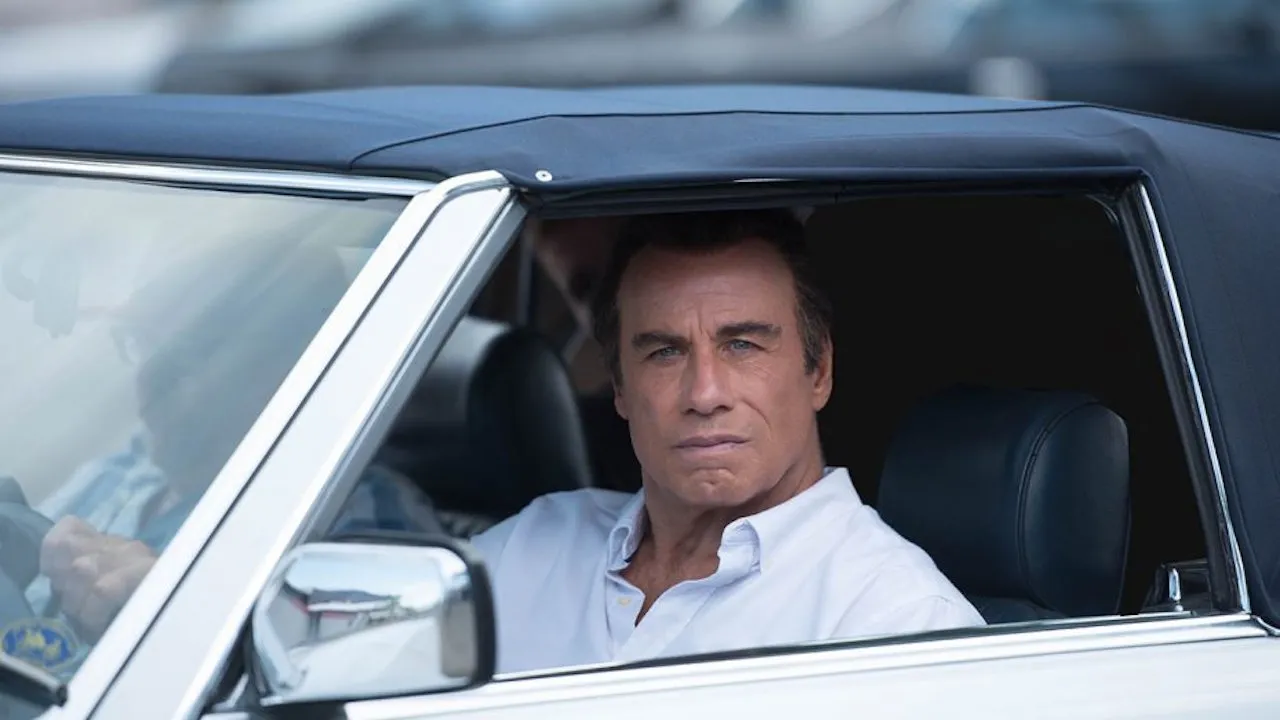What might the individual in the driver’s seat be thinking about? Given the individual's serious and reflective expression while looking out the window, he could be contemplating a recent event, thinking about an upcoming meeting, or simply observing the surroundings with a deep focus. 